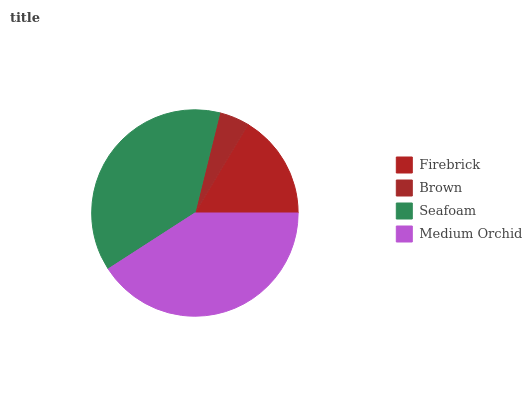Is Brown the minimum?
Answer yes or no. Yes. Is Medium Orchid the maximum?
Answer yes or no. Yes. Is Seafoam the minimum?
Answer yes or no. No. Is Seafoam the maximum?
Answer yes or no. No. Is Seafoam greater than Brown?
Answer yes or no. Yes. Is Brown less than Seafoam?
Answer yes or no. Yes. Is Brown greater than Seafoam?
Answer yes or no. No. Is Seafoam less than Brown?
Answer yes or no. No. Is Seafoam the high median?
Answer yes or no. Yes. Is Firebrick the low median?
Answer yes or no. Yes. Is Medium Orchid the high median?
Answer yes or no. No. Is Medium Orchid the low median?
Answer yes or no. No. 